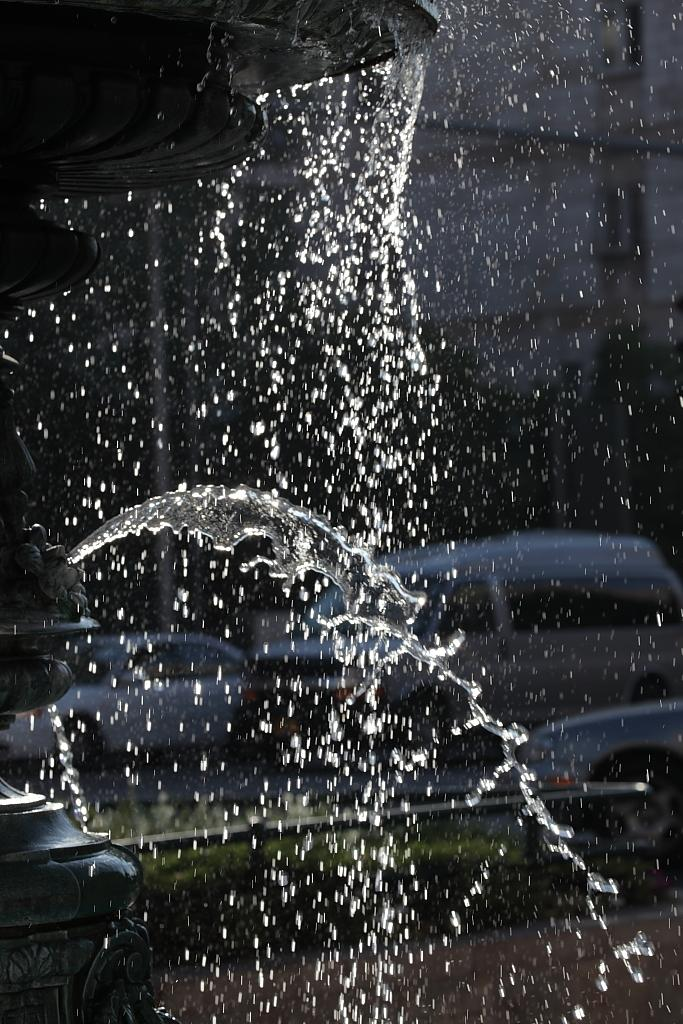What is the main subject in the foreground of the picture? There is a fountain in the foreground of the picture. What can be seen in the foreground of the picture besides the fountain? There is water in the foreground of the picture. What can be seen in the background of the picture? There are buildings and cars in the background of the picture. How would you describe the visibility of the background in the picture? The background is not clear. How many girls are participating in the protest in the image? There is no protest or girls present in the image; it features a fountain and water in the foreground, with buildings and cars in the background. What is the chance of winning a prize in the image? There is no indication of a prize or any game of chance in the image. 